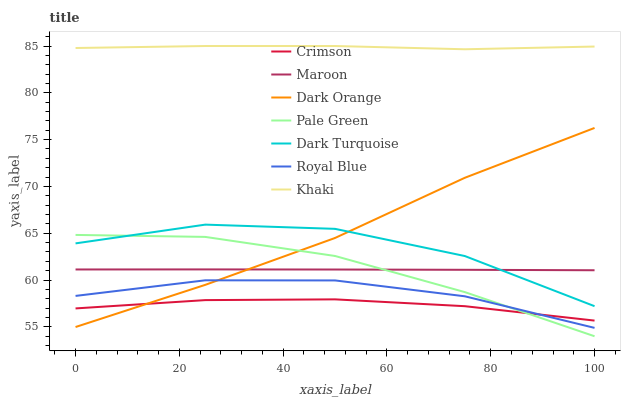Does Crimson have the minimum area under the curve?
Answer yes or no. Yes. Does Khaki have the maximum area under the curve?
Answer yes or no. Yes. Does Dark Turquoise have the minimum area under the curve?
Answer yes or no. No. Does Dark Turquoise have the maximum area under the curve?
Answer yes or no. No. Is Maroon the smoothest?
Answer yes or no. Yes. Is Dark Turquoise the roughest?
Answer yes or no. Yes. Is Khaki the smoothest?
Answer yes or no. No. Is Khaki the roughest?
Answer yes or no. No. Does Pale Green have the lowest value?
Answer yes or no. Yes. Does Dark Turquoise have the lowest value?
Answer yes or no. No. Does Khaki have the highest value?
Answer yes or no. Yes. Does Dark Turquoise have the highest value?
Answer yes or no. No. Is Maroon less than Khaki?
Answer yes or no. Yes. Is Khaki greater than Maroon?
Answer yes or no. Yes. Does Maroon intersect Dark Turquoise?
Answer yes or no. Yes. Is Maroon less than Dark Turquoise?
Answer yes or no. No. Is Maroon greater than Dark Turquoise?
Answer yes or no. No. Does Maroon intersect Khaki?
Answer yes or no. No. 